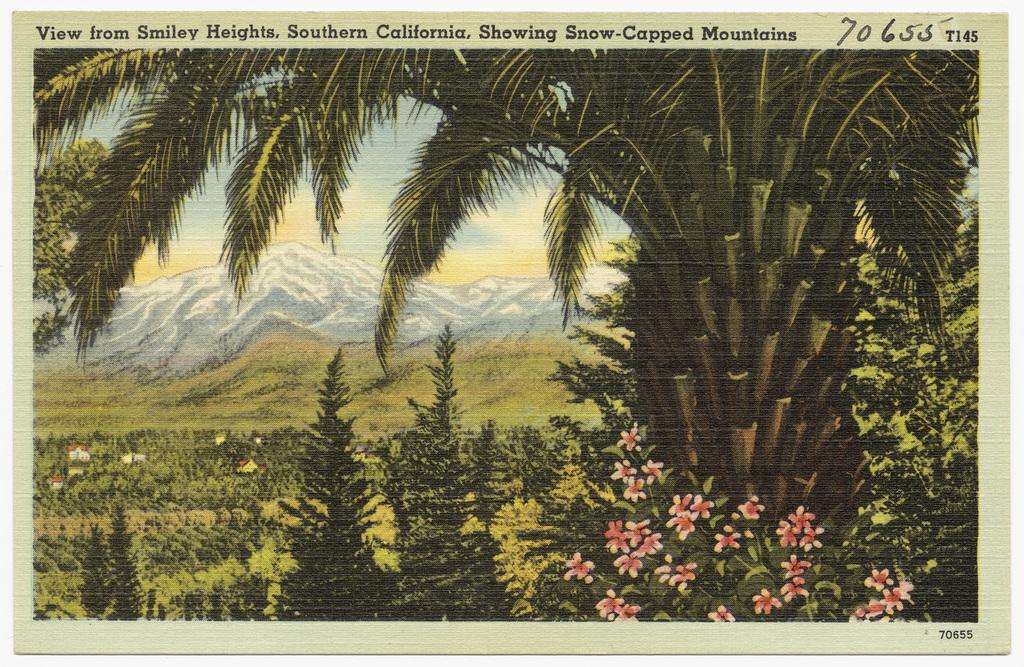What is depicted on the poster in the image? The poster contains trees, plants, flowers, grass, mountains, and the sky. What type of natural elements can be seen on the poster? The poster contains trees, plants, flowers, grass, mountains, and the sky. Is there any text on the poster? Yes, there is text at the top of the poster. What type of business is being advertised on the poster? There is no business being advertised on the poster; it contains natural elements and text. Can you see a guitar in the image? There is no guitar present in the image. 